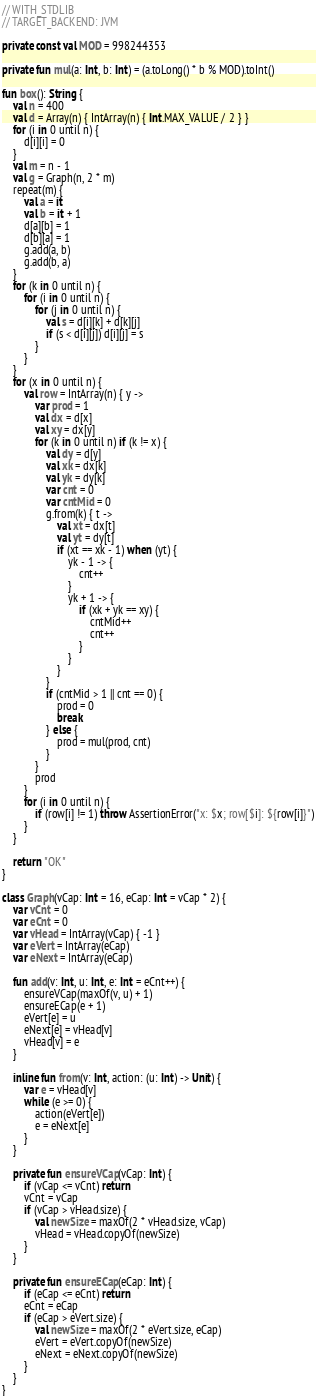Convert code to text. <code><loc_0><loc_0><loc_500><loc_500><_Kotlin_>// WITH_STDLIB
// TARGET_BACKEND: JVM

private const val MOD = 998244353

private fun mul(a: Int, b: Int) = (a.toLong() * b % MOD).toInt()

fun box(): String {
    val n = 400
    val d = Array(n) { IntArray(n) { Int.MAX_VALUE / 2 } }
    for (i in 0 until n) {
        d[i][i] = 0
    }
    val m = n - 1
    val g = Graph(n, 2 * m)
    repeat(m) {
        val a = it
        val b = it + 1
        d[a][b] = 1
        d[b][a] = 1
        g.add(a, b)
        g.add(b, a)
    }
    for (k in 0 until n) {
        for (i in 0 until n) {
            for (j in 0 until n) {
                val s = d[i][k] + d[k][j]
                if (s < d[i][j]) d[i][j] = s
            }
        }
    }
    for (x in 0 until n) {
        val row = IntArray(n) { y ->
            var prod = 1
            val dx = d[x]
            val xy = dx[y]
            for (k in 0 until n) if (k != x) {
                val dy = d[y]
                val xk = dx[k]
                val yk = dy[k]
                var cnt = 0
                var cntMid = 0
                g.from(k) { t ->
                    val xt = dx[t]
                    val yt = dy[t]
                    if (xt == xk - 1) when (yt) {
                        yk - 1 -> {
                            cnt++
                        }
                        yk + 1 -> {
                            if (xk + yk == xy) {
                                cntMid++
                                cnt++
                            }
                        }
                    }
                }
                if (cntMid > 1 || cnt == 0) {
                    prod = 0
                    break
                } else {
                    prod = mul(prod, cnt)
                }
            }
            prod
        }
        for (i in 0 until n) {
            if (row[i] != 1) throw AssertionError("x: $x; row[$i]: ${row[i]}")
        }
    }

    return "OK"
}

class Graph(vCap: Int = 16, eCap: Int = vCap * 2) {
    var vCnt = 0
    var eCnt = 0
    var vHead = IntArray(vCap) { -1 }
    var eVert = IntArray(eCap)
    var eNext = IntArray(eCap)

    fun add(v: Int, u: Int, e: Int = eCnt++) {
        ensureVCap(maxOf(v, u) + 1)
        ensureECap(e + 1)
        eVert[e] = u
        eNext[e] = vHead[v]
        vHead[v] = e
    }

    inline fun from(v: Int, action: (u: Int) -> Unit) {
        var e = vHead[v]
        while (e >= 0) {
            action(eVert[e])
            e = eNext[e]
        }
    }

    private fun ensureVCap(vCap: Int) {
        if (vCap <= vCnt) return
        vCnt = vCap
        if (vCap > vHead.size) {
            val newSize = maxOf(2 * vHead.size, vCap)
            vHead = vHead.copyOf(newSize)
        }
    }

    private fun ensureECap(eCap: Int) {
        if (eCap <= eCnt) return
        eCnt = eCap
        if (eCap > eVert.size) {
            val newSize = maxOf(2 * eVert.size, eCap)
            eVert = eVert.copyOf(newSize)
            eNext = eNext.copyOf(newSize)
        }
    }
}
</code> 